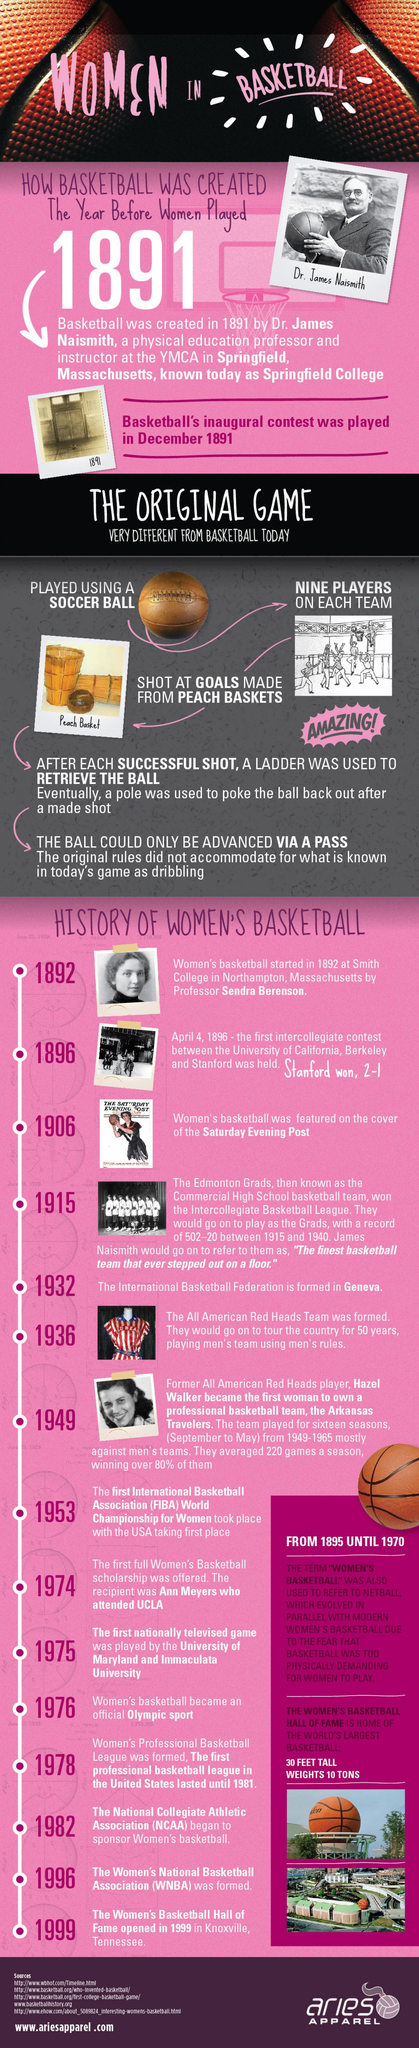When was a scholarship offered for women playing basketball, 1895, 1970, or 1974?
Answer the question with a short phrase. 1974 